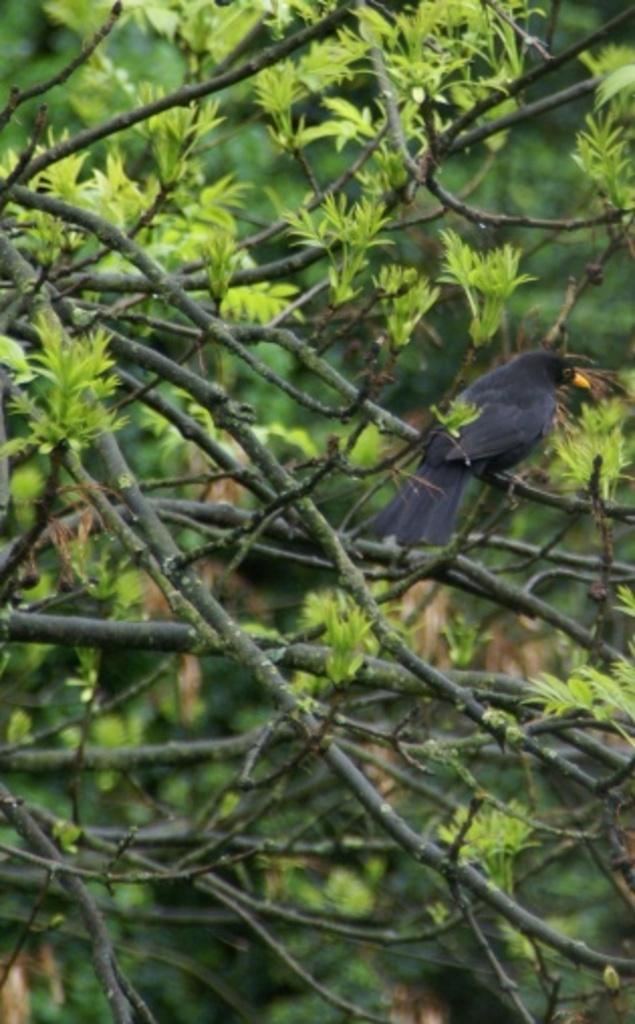What type of vegetation can be seen in the image? There are trees in the image. Is there any wildlife present in the image? Yes, a crow is sitting on a stem of a tree in the image. What can be observed about the trees in the image? Leaves are present on the trees. Can you see a cannon at the seashore in the image? There is no cannon or seashore present in the image; it features trees with a crow and leaves. 